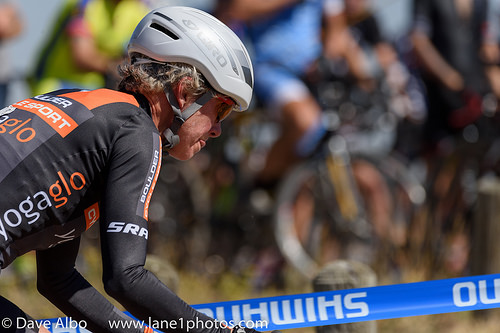<image>
Is the helmet on the jersey? No. The helmet is not positioned on the jersey. They may be near each other, but the helmet is not supported by or resting on top of the jersey. 